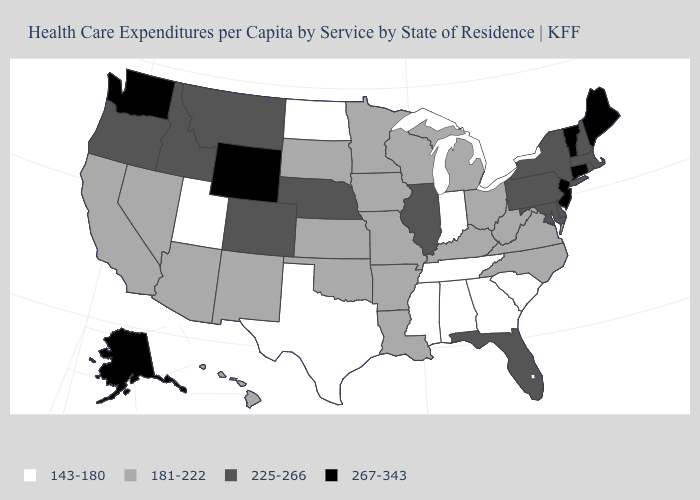Name the states that have a value in the range 181-222?
Quick response, please. Arizona, Arkansas, California, Hawaii, Iowa, Kansas, Kentucky, Louisiana, Michigan, Minnesota, Missouri, Nevada, New Mexico, North Carolina, Ohio, Oklahoma, South Dakota, Virginia, West Virginia, Wisconsin. What is the highest value in the USA?
Short answer required. 267-343. How many symbols are there in the legend?
Concise answer only. 4. Does Massachusetts have the same value as Indiana?
Quick response, please. No. What is the value of Washington?
Quick response, please. 267-343. What is the lowest value in the West?
Concise answer only. 143-180. What is the highest value in the USA?
Be succinct. 267-343. Name the states that have a value in the range 267-343?
Quick response, please. Alaska, Connecticut, Maine, New Jersey, Vermont, Washington, Wyoming. What is the value of Washington?
Concise answer only. 267-343. Does Arkansas have a higher value than Texas?
Give a very brief answer. Yes. What is the lowest value in states that border California?
Keep it brief. 181-222. Which states have the lowest value in the USA?
Answer briefly. Alabama, Georgia, Indiana, Mississippi, North Dakota, South Carolina, Tennessee, Texas, Utah. Name the states that have a value in the range 143-180?
Write a very short answer. Alabama, Georgia, Indiana, Mississippi, North Dakota, South Carolina, Tennessee, Texas, Utah. What is the value of Louisiana?
Keep it brief. 181-222. Which states have the lowest value in the USA?
Keep it brief. Alabama, Georgia, Indiana, Mississippi, North Dakota, South Carolina, Tennessee, Texas, Utah. 